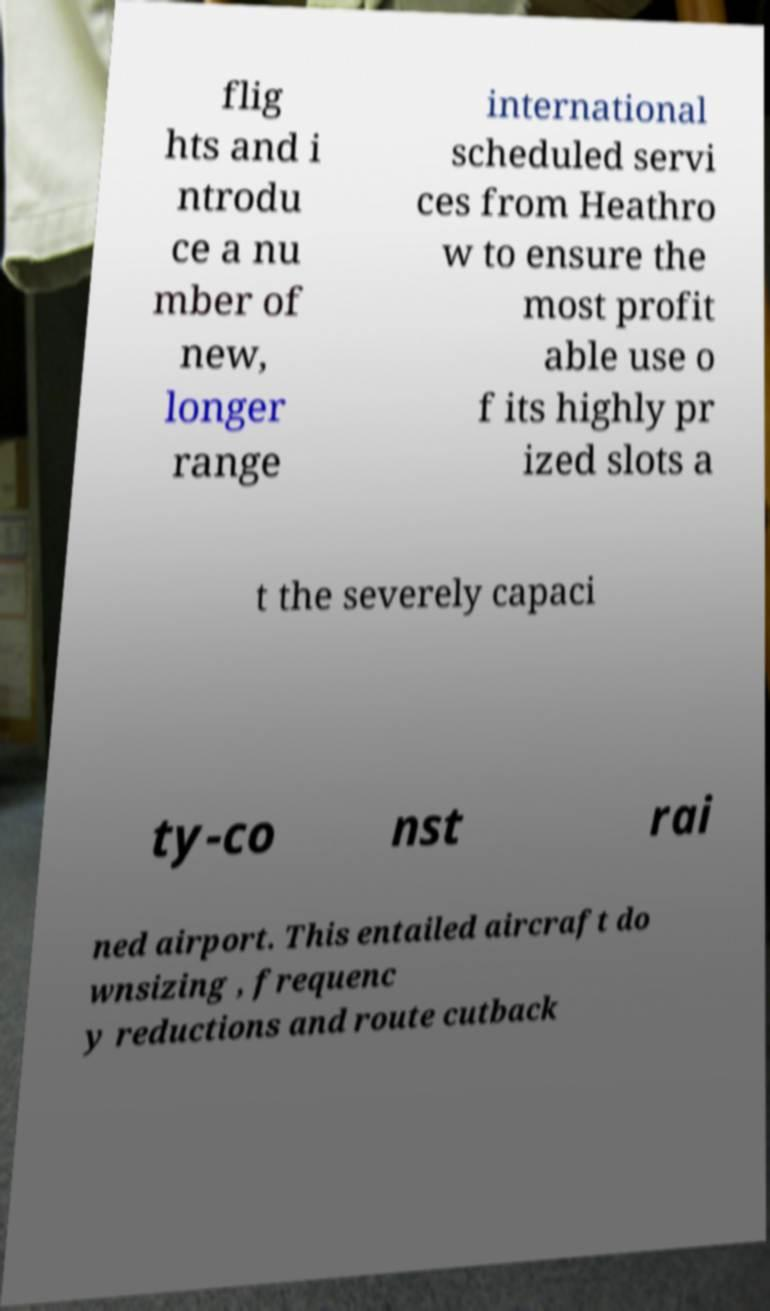There's text embedded in this image that I need extracted. Can you transcribe it verbatim? flig hts and i ntrodu ce a nu mber of new, longer range international scheduled servi ces from Heathro w to ensure the most profit able use o f its highly pr ized slots a t the severely capaci ty-co nst rai ned airport. This entailed aircraft do wnsizing , frequenc y reductions and route cutback 